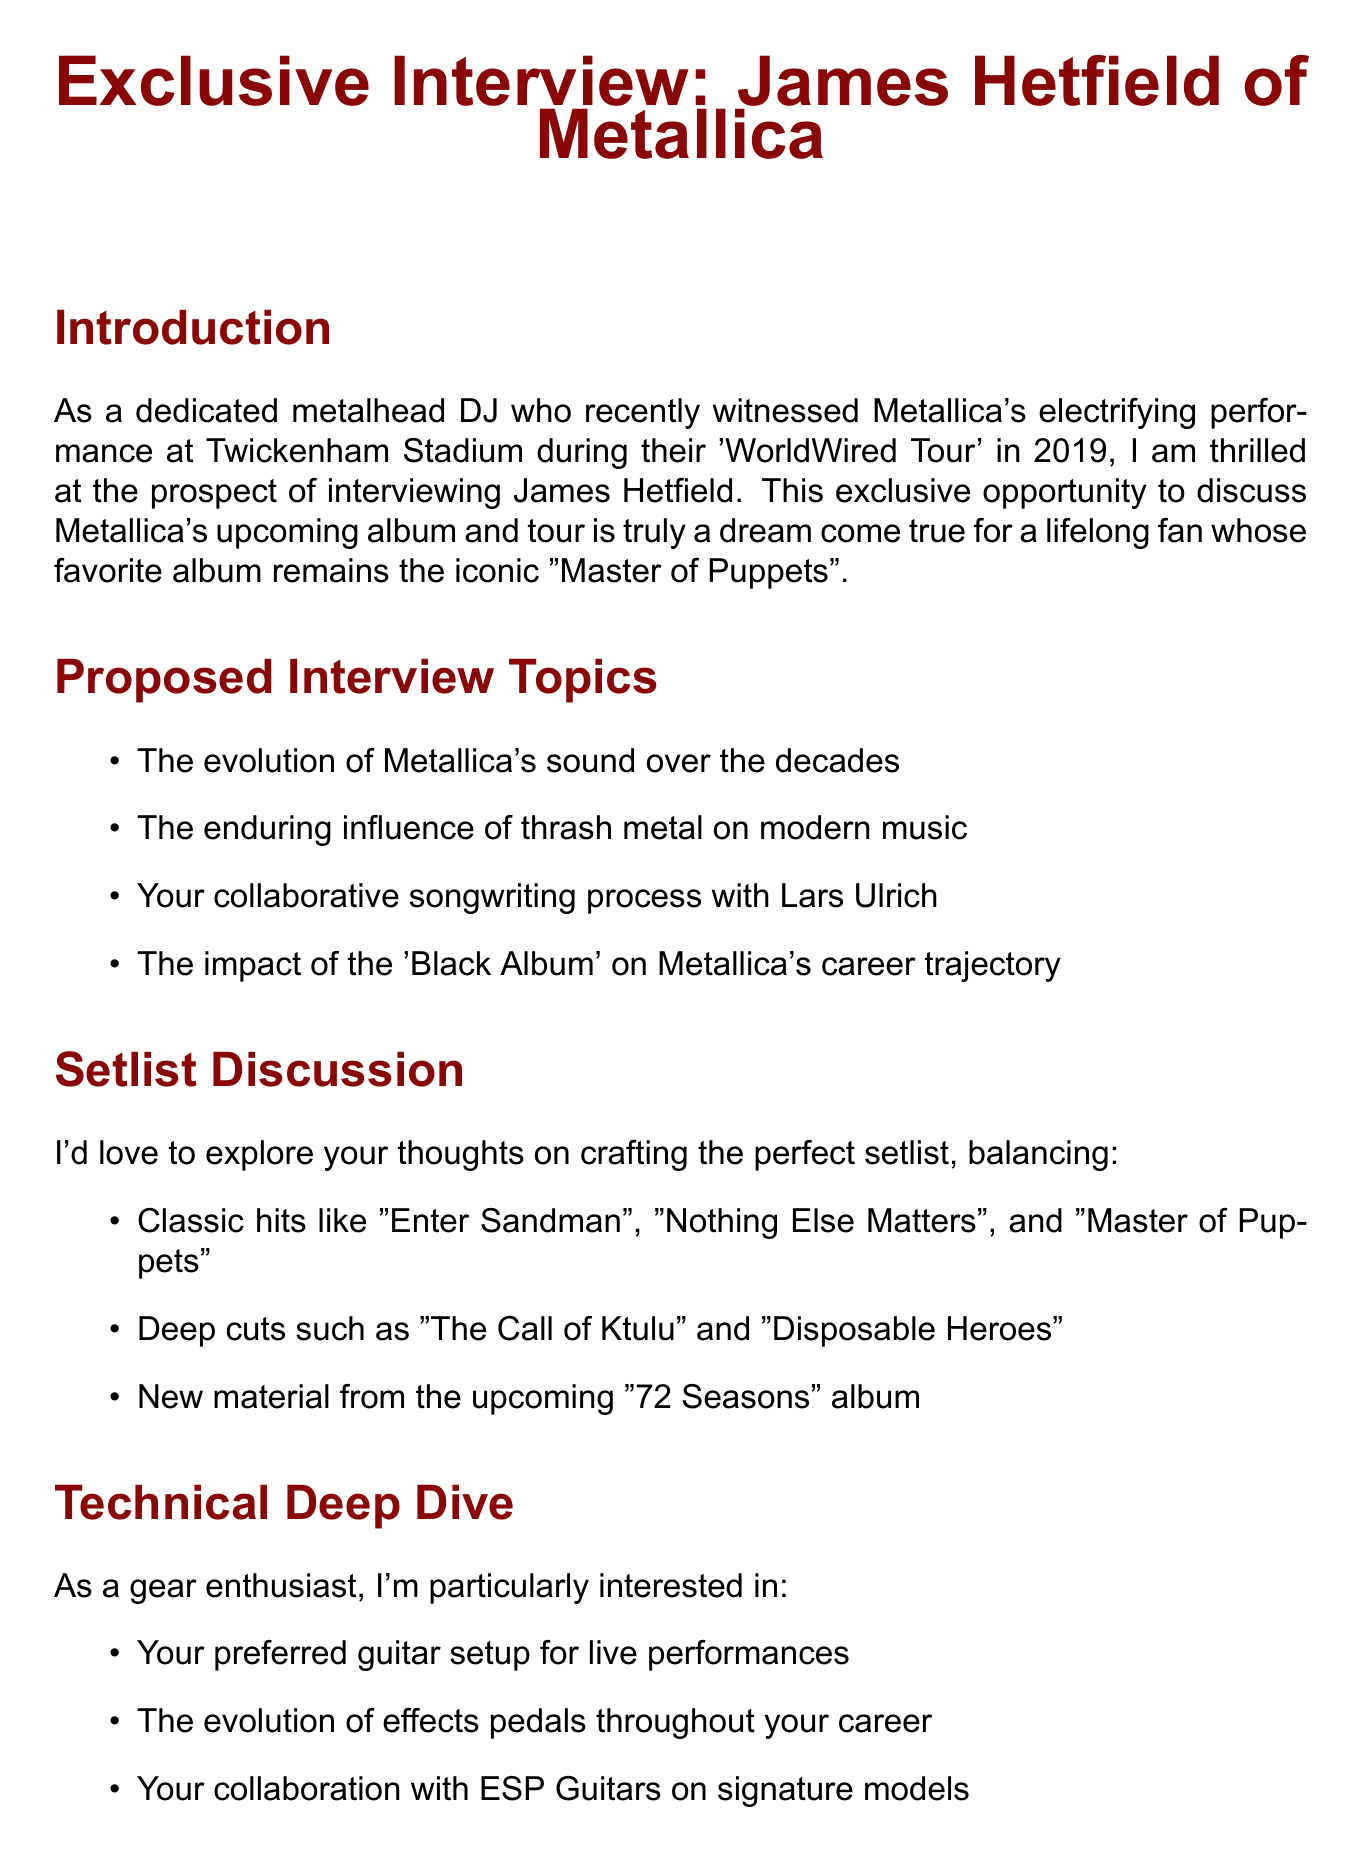What is the subject of the email? The subject of the email, as stated in the document, provides the main focus of the communication, which is an exclusive interview opportunity with James Hetfield.
Answer: Exclusive Interview Opportunity: James Hetfield of Metallica Who is the lead guitarist mentioned in the email? The email specifies the name of the lead guitarist who is the main subject of the interview opportunity.
Answer: James Hetfield What is the favorite album of the sender? The document clearly states the sender's favorite album, which reveals their deep connection and admiration for the band.
Answer: Master of Puppets What year did the sender attend the concert? The email contains a specific year when the sender experienced a live performance, indicating their longtime fandom.
Answer: 2019 Name one classic hit mentioned for setlist discussion. The document lists several classic hits that could be discussed in the context of crafting a setlist, demonstrating the band's iconic status.
Answer: Enter Sandman What is the upcoming album that will be discussed? The email mentions the title of the new album, emphasizing what the interview will focus on regarding Metallica's future.
Answer: 72 Seasons How is the tone of the closing expressed? The closing section of the email reflects the overall mood of appreciation and eagerness for the interview opportunity.
Answer: Gratitude Which performance aspect is referenced for discussion? The email refers to the guitarist's preferences in terms of gear, which is significant for interviews involving musicians.
Answer: Guitar setup What type of questions does the sender intend to ask? The document outlines the nature of inquiries to be covered in the interview, giving a glimpse into the sender's preparation.
Answer: Technical questions 